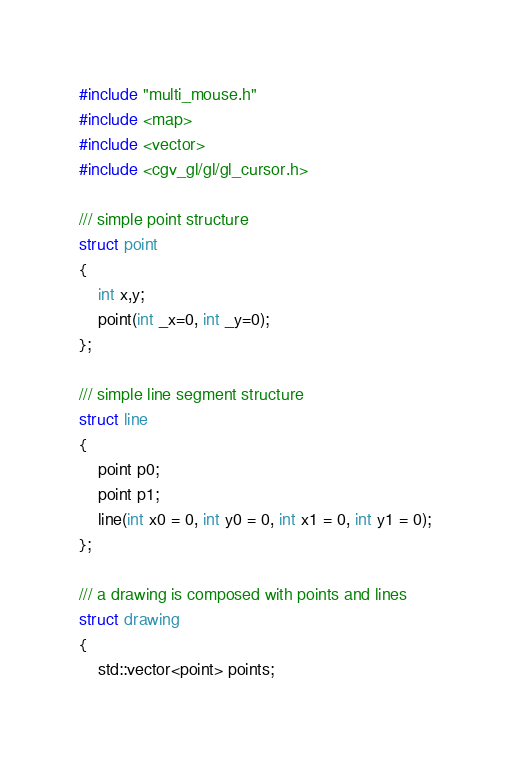Convert code to text. <code><loc_0><loc_0><loc_500><loc_500><_C_>#include "multi_mouse.h"
#include <map>
#include <vector>
#include <cgv_gl/gl/gl_cursor.h>

/// simple point structure
struct point
{
	int x,y;
	point(int _x=0, int _y=0);
};

/// simple line segment structure
struct line
{
	point p0;
	point p1;
	line(int x0 = 0, int y0 = 0, int x1 = 0, int y1 = 0);
};

/// a drawing is composed with points and lines
struct drawing
{
	std::vector<point> points;</code> 